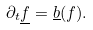<formula> <loc_0><loc_0><loc_500><loc_500>\partial _ { t } \underline { f } = \underline { b } ( f ) .</formula> 